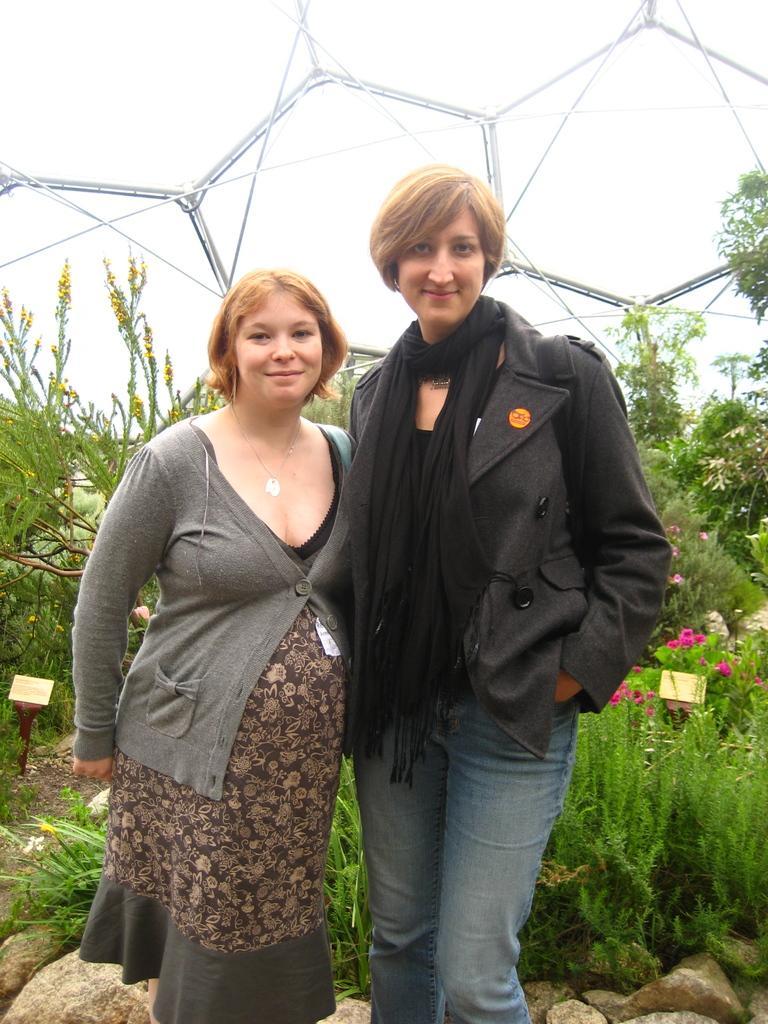Describe this image in one or two sentences. The woman on the left corner of the picture wearing a grey jacket is standing beside the woman who is wearing a black jacket. Both of them are smiling. Behind them, we see plants and trees. At the top of the picture, we see the sky and beam and at the bottom of the picture, we see rocks. 